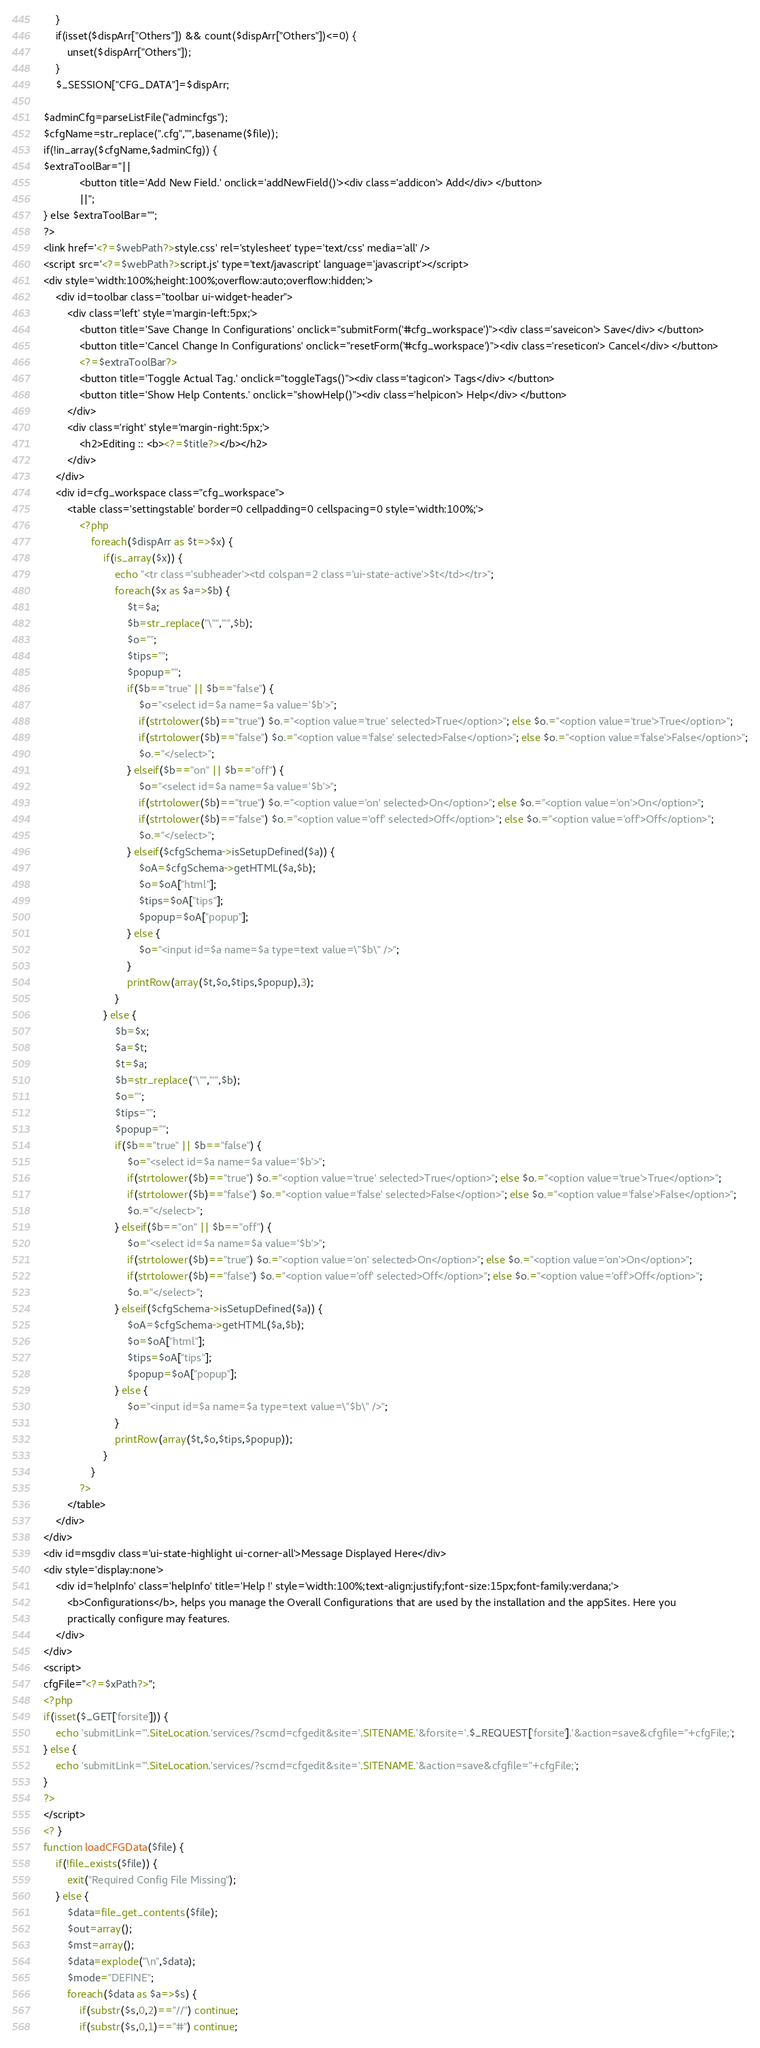<code> <loc_0><loc_0><loc_500><loc_500><_PHP_>	}
	if(isset($dispArr["Others"]) && count($dispArr["Others"])<=0) {
		unset($dispArr["Others"]);
	}
	$_SESSION["CFG_DATA"]=$dispArr;

$adminCfg=parseListFile("admincfgs");
$cfgName=str_replace(".cfg","",basename($file));
if(!in_array($cfgName,$adminCfg)) {
$extraToolBar="||
			<button title='Add New Field.' onclick='addNewField()'><div class='addicon'> Add</div> </button>
			||";
} else $extraToolBar="";
?>
<link href='<?=$webPath?>style.css' rel='stylesheet' type='text/css' media='all' />
<script src='<?=$webPath?>script.js' type='text/javascript' language='javascript'></script>
<div style='width:100%;height:100%;overflow:auto;overflow:hidden;'>
	<div id=toolbar class="toolbar ui-widget-header">
		<div class='left' style='margin-left:5px;'>
			<button title='Save Change In Configurations' onclick="submitForm('#cfg_workspace')"><div class='saveicon'> Save</div> </button>
			<button title='Cancel Change In Configurations' onclick="resetForm('#cfg_workspace')"><div class='reseticon'> Cancel</div> </button>
			<?=$extraToolBar?>
			<button title='Toggle Actual Tag.' onclick="toggleTags()"><div class='tagicon'> Tags</div> </button>
			<button title='Show Help Contents.' onclick="showHelp()"><div class='helpicon'> Help</div> </button>
		</div>
		<div class='right' style='margin-right:5px;'>
			<h2>Editing :: <b><?=$title?></b></h2>
		</div>
	</div>
	<div id=cfg_workspace class="cfg_workspace">
		<table class='settingstable' border=0 cellpadding=0 cellspacing=0 style='width:100%;'>
			<?php
				foreach($dispArr as $t=>$x) {
					if(is_array($x)) {
						echo "<tr class='subheader'><td colspan=2 class='ui-state-active'>$t</td></tr>";
						foreach($x as $a=>$b) {
							$t=$a;
							$b=str_replace("\"","'",$b);
							$o="";
							$tips="";
							$popup="";
							if($b=="true" || $b=="false") {
								$o="<select id=$a name=$a value='$b'>";
								if(strtolower($b)=="true") $o.="<option value='true' selected>True</option>"; else $o.="<option value='true'>True</option>";
								if(strtolower($b)=="false") $o.="<option value='false' selected>False</option>"; else $o.="<option value='false'>False</option>";
								$o.="</select>";
							} elseif($b=="on" || $b=="off") {
								$o="<select id=$a name=$a value='$b'>";
								if(strtolower($b)=="true") $o.="<option value='on' selected>On</option>"; else $o.="<option value='on'>On</option>";
								if(strtolower($b)=="false") $o.="<option value='off' selected>Off</option>"; else $o.="<option value='off'>Off</option>";
								$o.="</select>";
							} elseif($cfgSchema->isSetupDefined($a)) {
								$oA=$cfgSchema->getHTML($a,$b);
								$o=$oA["html"];
								$tips=$oA["tips"];
								$popup=$oA["popup"];
							} else {
								$o="<input id=$a name=$a type=text value=\"$b\" />";
							}
							printRow(array($t,$o,$tips,$popup),3);
						}
					} else {
						$b=$x;
						$a=$t;
						$t=$a;
						$b=str_replace("\"","'",$b);
						$o="";
						$tips="";
						$popup="";
						if($b=="true" || $b=="false") {
							$o="<select id=$a name=$a value='$b'>";
							if(strtolower($b)=="true") $o.="<option value='true' selected>True</option>"; else $o.="<option value='true'>True</option>";
							if(strtolower($b)=="false") $o.="<option value='false' selected>False</option>"; else $o.="<option value='false'>False</option>";
							$o.="</select>";
						} elseif($b=="on" || $b=="off") {
							$o="<select id=$a name=$a value='$b'>";
							if(strtolower($b)=="true") $o.="<option value='on' selected>On</option>"; else $o.="<option value='on'>On</option>";
							if(strtolower($b)=="false") $o.="<option value='off' selected>Off</option>"; else $o.="<option value='off'>Off</option>";
							$o.="</select>";
						} elseif($cfgSchema->isSetupDefined($a)) {
							$oA=$cfgSchema->getHTML($a,$b);
							$o=$oA["html"];
							$tips=$oA["tips"];
							$popup=$oA["popup"];
						} else {
							$o="<input id=$a name=$a type=text value=\"$b\" />";
						}
						printRow(array($t,$o,$tips,$popup));
					}
				}
			?>
		</table>
	</div>
</div>
<div id=msgdiv class='ui-state-highlight ui-corner-all'>Message Displayed Here</div>
<div style='display:none'>
	<div id='helpInfo' class='helpInfo' title='Help !' style='width:100%;text-align:justify;font-size:15px;font-family:verdana;'>
		<b>Configurations</b>, helps you manage the Overall Configurations that are used by the installation and the appSites. Here you
		practically configure may features.
	</div>
</div>
<script>
cfgFile="<?=$xPath?>";
<?php
if(isset($_GET['forsite'])) {
	echo 'submitLink="'.SiteLocation.'services/?scmd=cfgedit&site='.SITENAME.'&forsite='.$_REQUEST['forsite'].'&action=save&cfgfile="+cfgFile;';
} else {
	echo 'submitLink="'.SiteLocation.'services/?scmd=cfgedit&site='.SITENAME.'&action=save&cfgfile="+cfgFile;';
}
?>
</script>
<? }
function loadCFGData($file) {
	if(!file_exists($file)) {
		exit("Required Config File Missing");
	} else {
		$data=file_get_contents($file);
		$out=array();
		$mst=array();
		$data=explode("\n",$data);
		$mode="DEFINE";
		foreach($data as $a=>$s) {
			if(substr($s,0,2)=="//") continue;
			if(substr($s,0,1)=="#") continue;</code> 